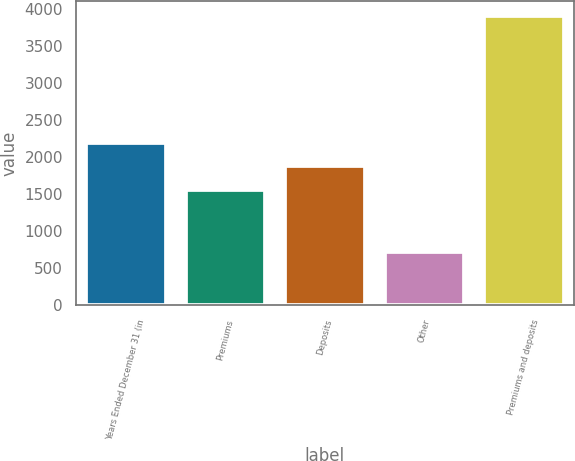Convert chart to OTSL. <chart><loc_0><loc_0><loc_500><loc_500><bar_chart><fcel>Years Ended December 31 (in<fcel>Premiums<fcel>Deposits<fcel>Other<fcel>Premiums and deposits<nl><fcel>2194.6<fcel>1554<fcel>1874.3<fcel>711<fcel>3914<nl></chart> 